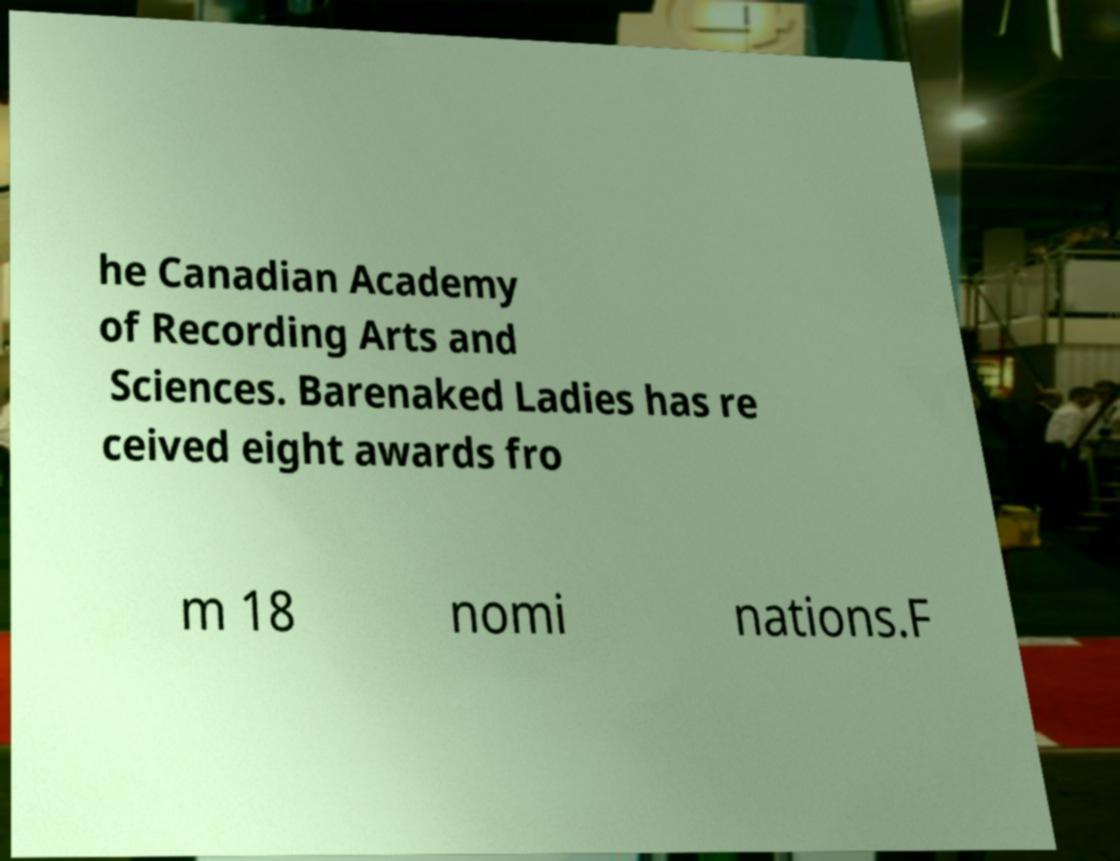There's text embedded in this image that I need extracted. Can you transcribe it verbatim? he Canadian Academy of Recording Arts and Sciences. Barenaked Ladies has re ceived eight awards fro m 18 nomi nations.F 